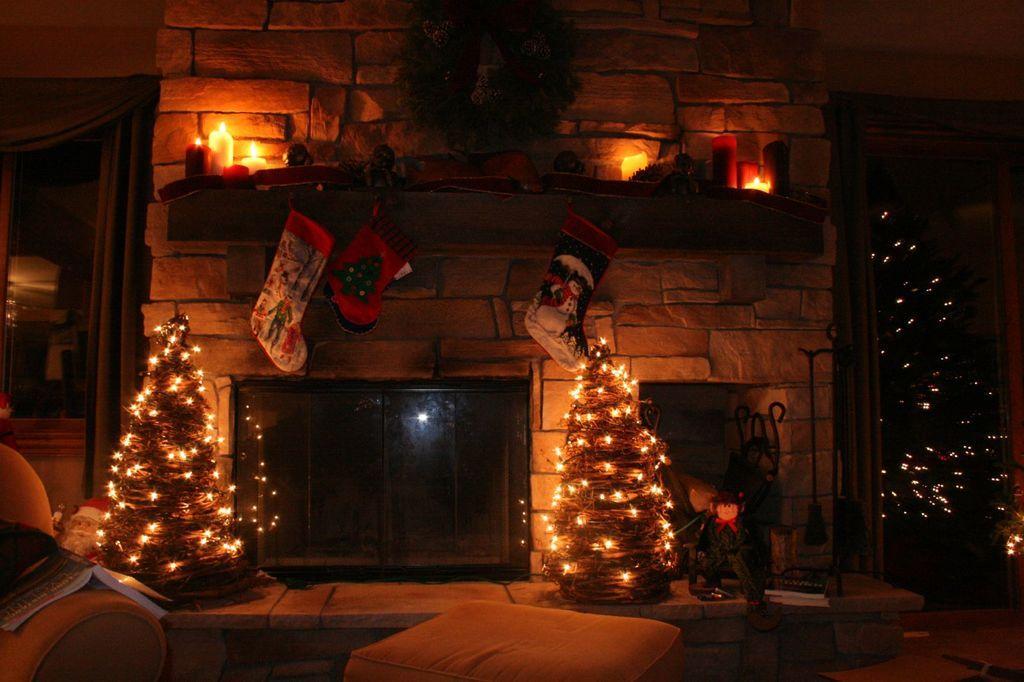Can you describe this image briefly? This picture is clicked inside the room. At the bottom, we see a stool and a sofa chair on which book is placed. Beside that, we see a table on which television and trees which are decorated with the lights are placed. Behind that, we see a white wall and a shelf on which candles are placed. We see the clothes or socks are hanged. On the right side, we see a tree which is decorated with the lights. On the left side, we see a glass door. This picture is clicked in the dark. 